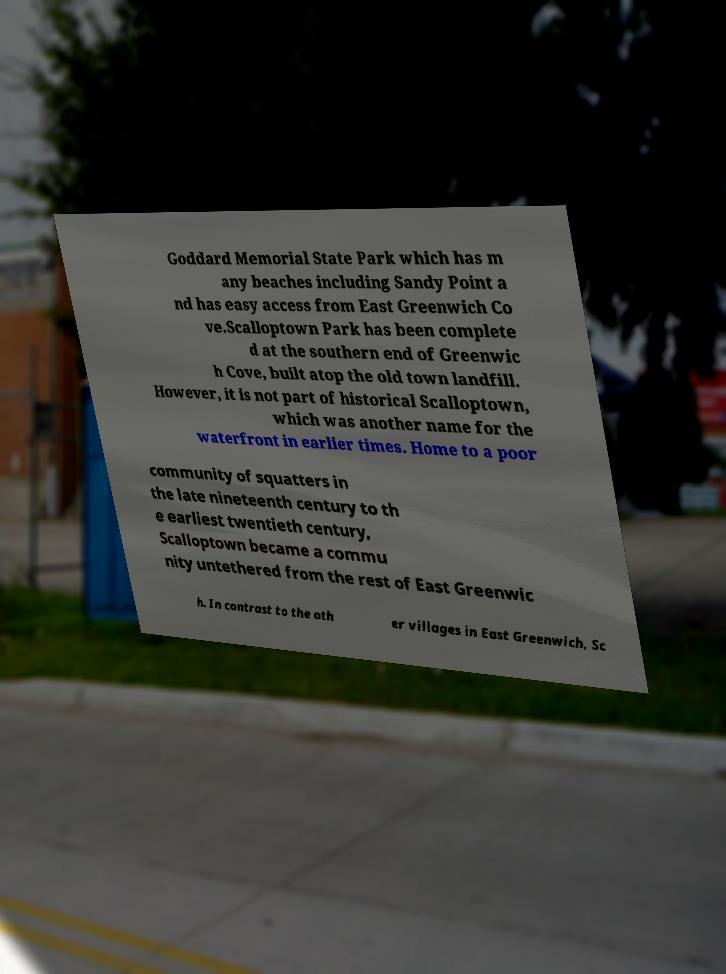There's text embedded in this image that I need extracted. Can you transcribe it verbatim? Goddard Memorial State Park which has m any beaches including Sandy Point a nd has easy access from East Greenwich Co ve.Scalloptown Park has been complete d at the southern end of Greenwic h Cove, built atop the old town landfill. However, it is not part of historical Scalloptown, which was another name for the waterfront in earlier times. Home to a poor community of squatters in the late nineteenth century to th e earliest twentieth century, Scalloptown became a commu nity untethered from the rest of East Greenwic h. In contrast to the oth er villages in East Greenwich, Sc 